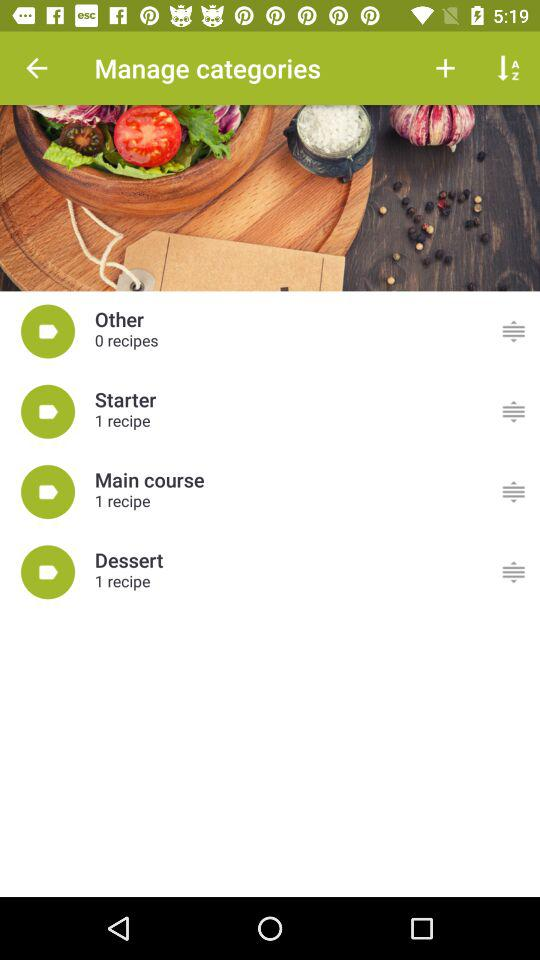How many recipes are there in the dessert category?
Answer the question using a single word or phrase. 1 